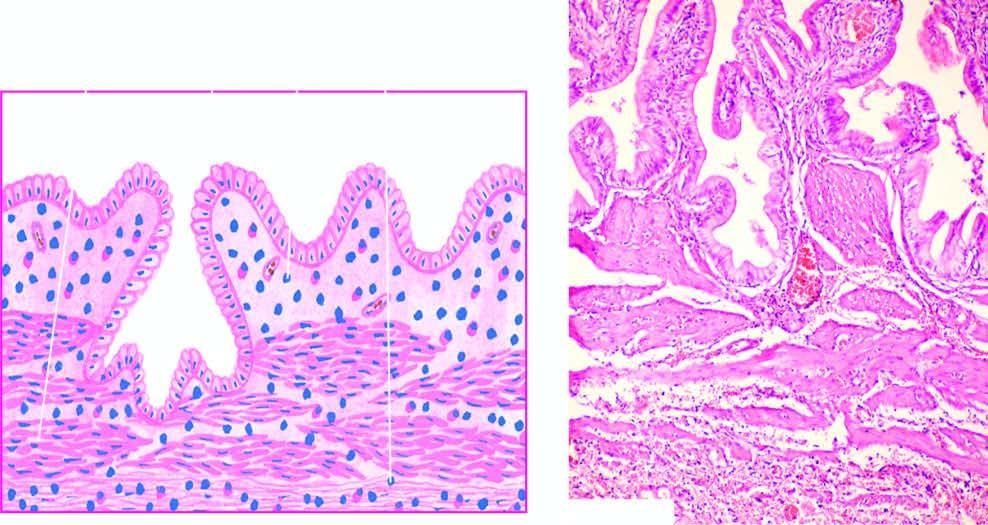s iron on absorption from upper small intestine present in subepithelial and perimuscular layers?
Answer the question using a single word or phrase. No 